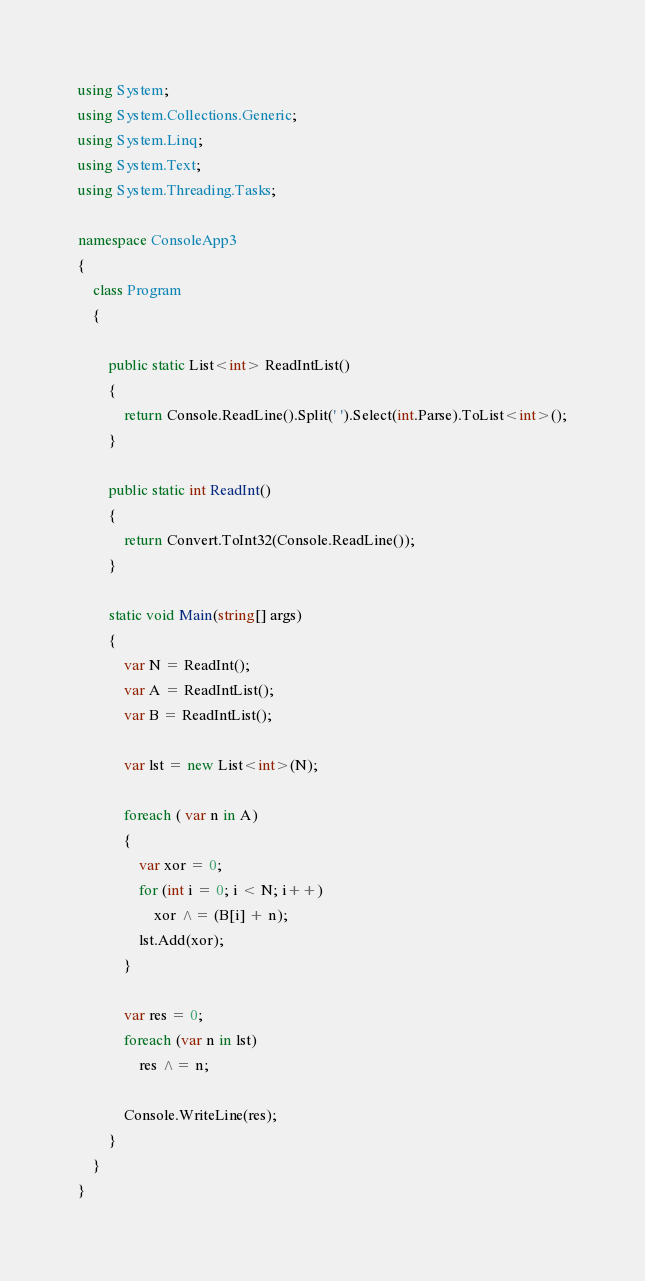Convert code to text. <code><loc_0><loc_0><loc_500><loc_500><_C#_>using System;
using System.Collections.Generic;
using System.Linq;
using System.Text;
using System.Threading.Tasks;

namespace ConsoleApp3
{
    class Program
    {

        public static List<int> ReadIntList()
        {
            return Console.ReadLine().Split(' ').Select(int.Parse).ToList<int>();
        }

        public static int ReadInt()
        {
            return Convert.ToInt32(Console.ReadLine());
        }

        static void Main(string[] args)
        {
            var N = ReadInt();
            var A = ReadIntList();
            var B = ReadIntList();

            var lst = new List<int>(N);

            foreach ( var n in A)
            {
                var xor = 0;
                for (int i = 0; i < N; i++)
                    xor ^= (B[i] + n);
                lst.Add(xor);
            }

            var res = 0;
            foreach (var n in lst)
                res ^= n;

            Console.WriteLine(res);
        }
    }
}
</code> 